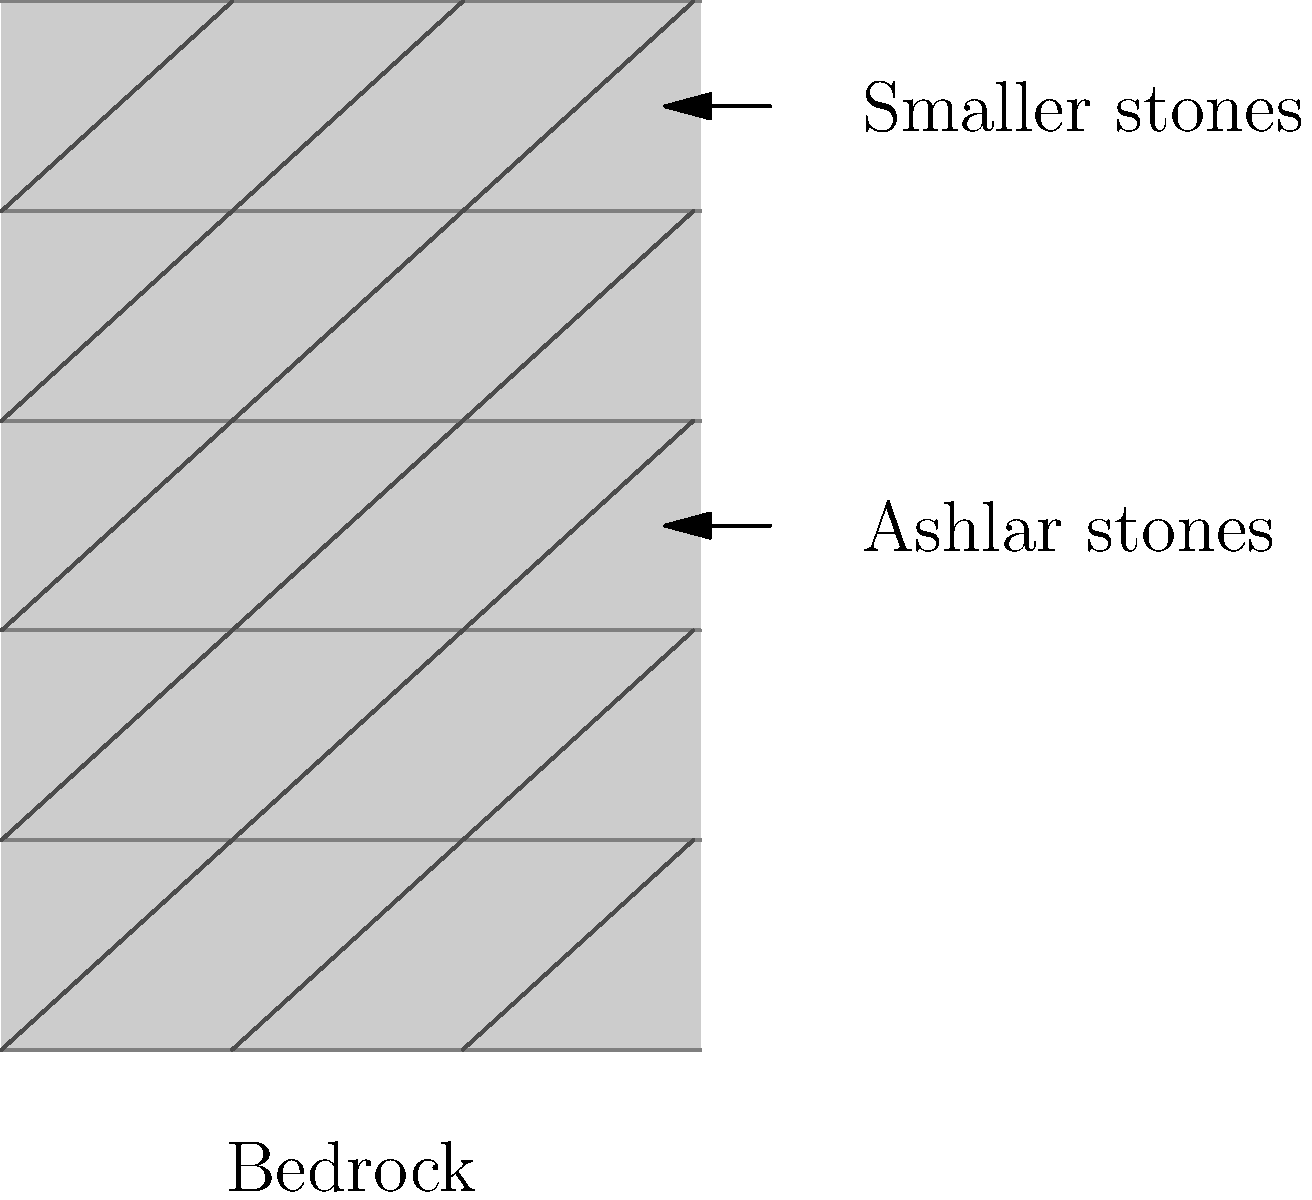Based on the cross-sectional diagram of the Western Wall, what construction technique was primarily used for its lower sections, and how does this reflect ancient Jewish engineering practices? To answer this question, let's analyze the diagram and consider the historical context:

1. The lower section of the wall consists of large, tightly fitted stones, known as ashlar masonry.

2. Ashlar masonry involves using large, precisely cut stones that are laid in horizontal courses without mortar.

3. This technique was commonly used in important structures in ancient times, including the Second Temple period (516 BCE - 70 CE) when the Western Wall was constructed.

4. The use of ashlar masonry reflects advanced engineering skills:
   a) It provides stability and durability to the structure.
   b) It demonstrates precision in stone cutting and placement.
   c) It allows for the construction of tall, load-bearing walls.

5. In Jewish tradition, this meticulous construction method can be seen as reflecting the importance of the Temple Mount and the dedication to creating a lasting structure.

6. The upper sections of the wall use smaller stones, which may represent later additions or repairs.

7. The foundation of the wall rests directly on bedrock, further enhancing its stability and longevity.

This construction method not only served a practical purpose but also held symbolic significance, representing the permanence and strength of the Jewish faith and its connection to Jerusalem.
Answer: Ashlar masonry, reflecting advanced ancient Jewish engineering practices focused on stability, precision, and longevity. 